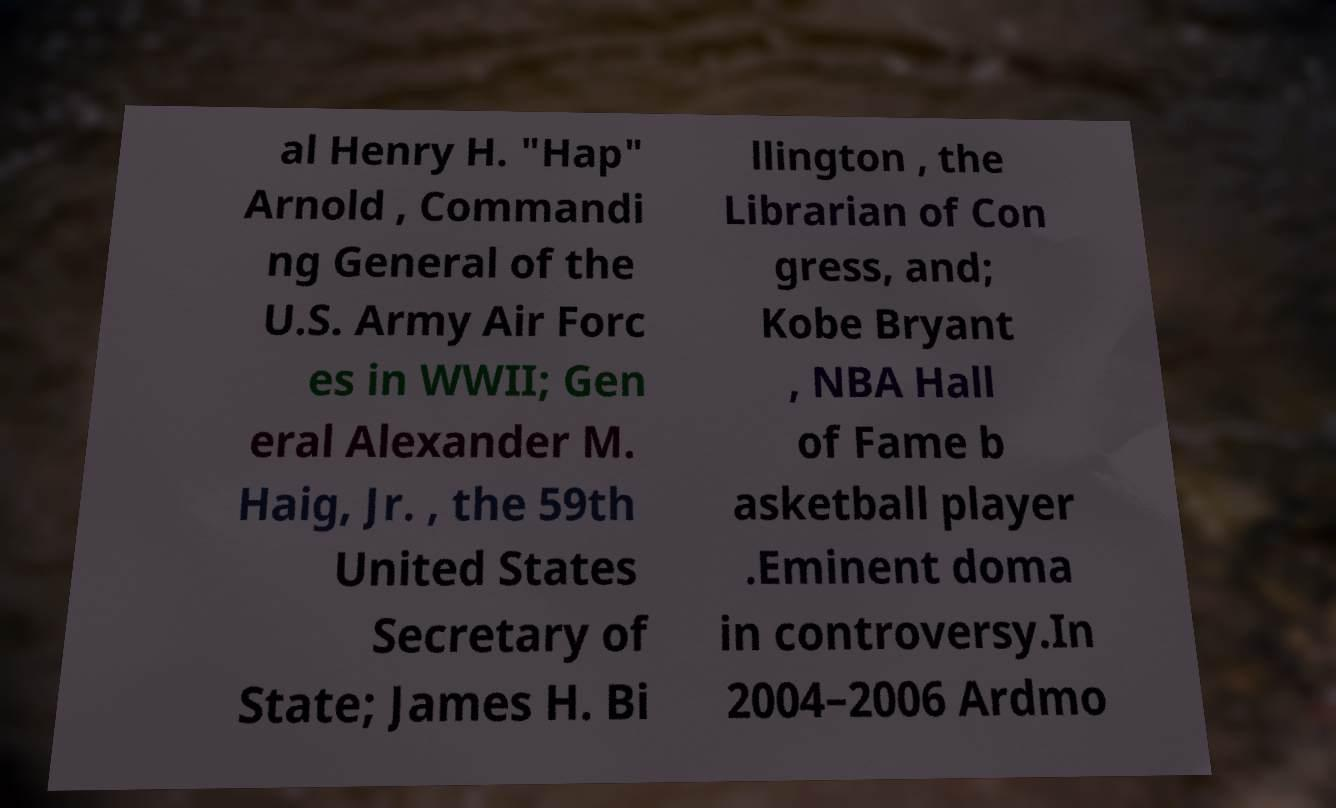Can you read and provide the text displayed in the image?This photo seems to have some interesting text. Can you extract and type it out for me? al Henry H. "Hap" Arnold , Commandi ng General of the U.S. Army Air Forc es in WWII; Gen eral Alexander M. Haig, Jr. , the 59th United States Secretary of State; James H. Bi llington , the Librarian of Con gress, and; Kobe Bryant , NBA Hall of Fame b asketball player .Eminent doma in controversy.In 2004–2006 Ardmo 